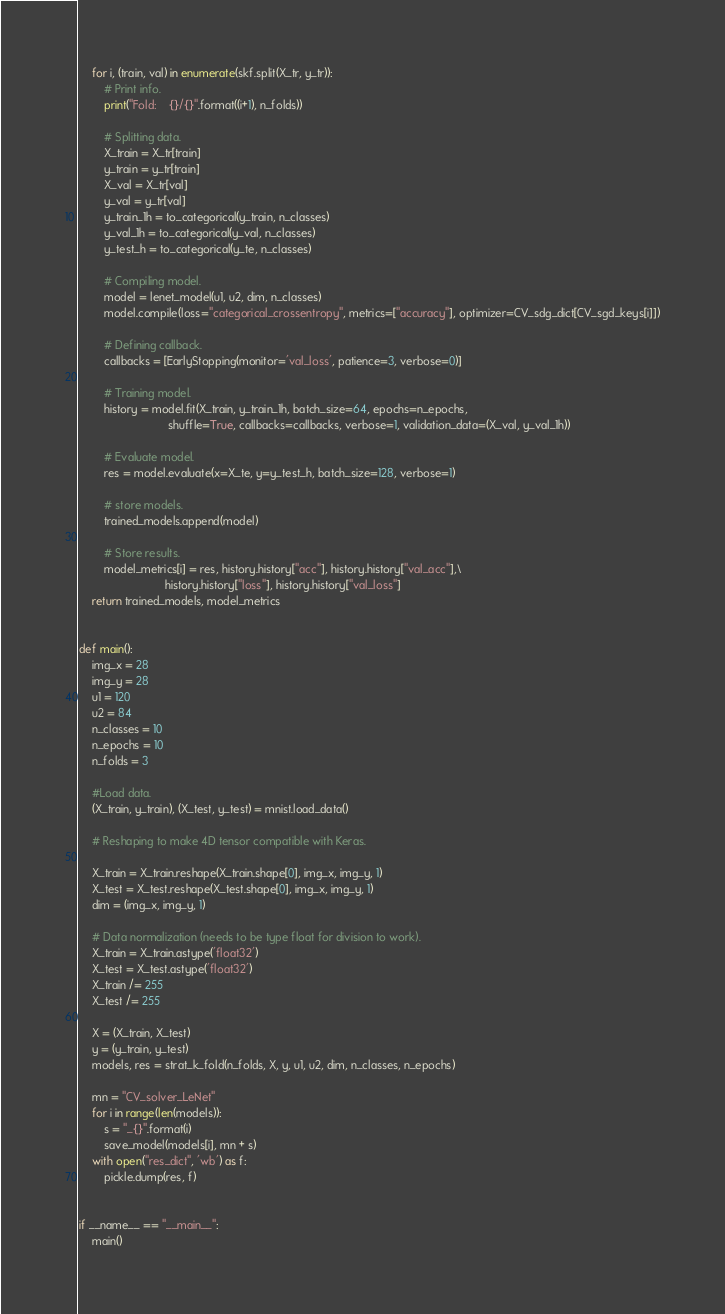<code> <loc_0><loc_0><loc_500><loc_500><_Python_>    for i, (train, val) in enumerate(skf.split(X_tr, y_tr)):
        # Print info.
        print("Fold:    {}/{}".format((i+1), n_folds))

        # Splitting data.
        X_train = X_tr[train]
        y_train = y_tr[train]
        X_val = X_tr[val]
        y_val = y_tr[val]
        y_train_1h = to_categorical(y_train, n_classes)
        y_val_1h = to_categorical(y_val, n_classes)
        y_test_h = to_categorical(y_te, n_classes)

        # Compiling model.
        model = lenet_model(u1, u2, dim, n_classes)
        model.compile(loss="categorical_crossentropy", metrics=["accuracy"], optimizer=CV_sdg_dict[CV_sgd_keys[i]])

        # Defining callback.
        callbacks = [EarlyStopping(monitor='val_loss', patience=3, verbose=0)]

        # Training model.
        history = model.fit(X_train, y_train_1h, batch_size=64, epochs=n_epochs,
                            shuffle=True, callbacks=callbacks, verbose=1, validation_data=(X_val, y_val_1h))

        # Evaluate model.
        res = model.evaluate(x=X_te, y=y_test_h, batch_size=128, verbose=1)

        # store models.
        trained_models.append(model)

        # Store results.
        model_metrics[i] = res, history.history["acc"], history.history["val_acc"],\
                           history.history["loss"], history.history["val_loss"]
    return trained_models, model_metrics


def main():
    img_x = 28
    img_y = 28
    u1 = 120
    u2 = 84
    n_classes = 10
    n_epochs = 10
    n_folds = 3

    #Load data.
    (X_train, y_train), (X_test, y_test) = mnist.load_data()

    # Reshaping to make 4D tensor compatible with Keras.

    X_train = X_train.reshape(X_train.shape[0], img_x, img_y, 1)
    X_test = X_test.reshape(X_test.shape[0], img_x, img_y, 1)
    dim = (img_x, img_y, 1)

    # Data normalization (needs to be type float for division to work).
    X_train = X_train.astype('float32')
    X_test = X_test.astype('float32')
    X_train /= 255
    X_test /= 255

    X = (X_train, X_test)
    y = (y_train, y_test)
    models, res = strat_k_fold(n_folds, X, y, u1, u2, dim, n_classes, n_epochs)

    mn = "CV_solver_LeNet"
    for i in range(len(models)):
        s = "_{}".format(i)
        save_model(models[i], mn + s)
    with open("res_dict", 'wb') as f:
        pickle.dump(res, f)


if __name__ == "__main__":
    main()

</code> 